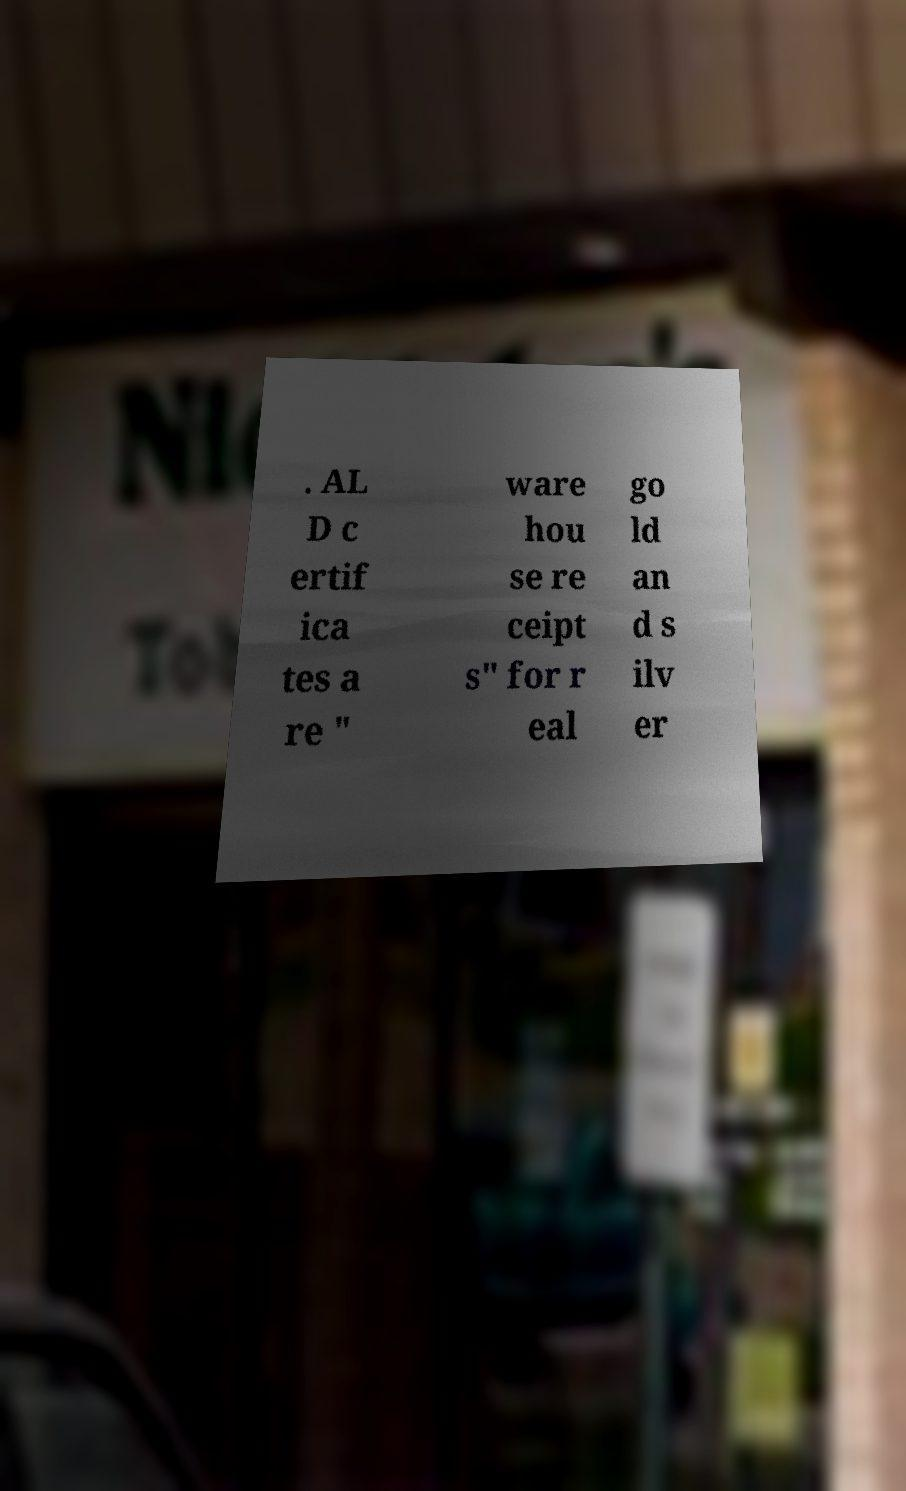What messages or text are displayed in this image? I need them in a readable, typed format. . AL D c ertif ica tes a re " ware hou se re ceipt s" for r eal go ld an d s ilv er 